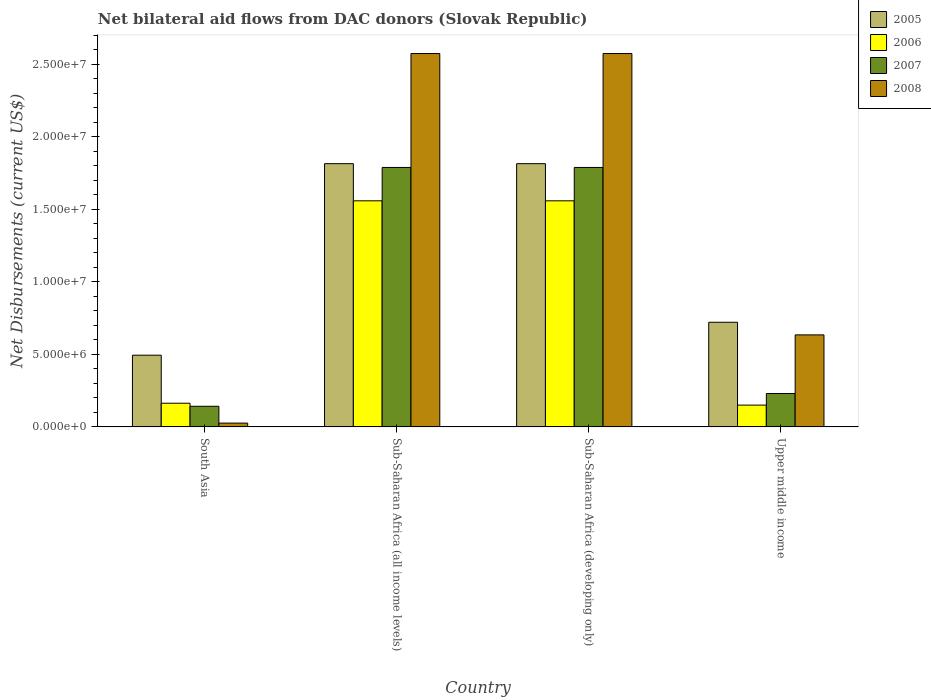Are the number of bars on each tick of the X-axis equal?
Make the answer very short. Yes. What is the label of the 2nd group of bars from the left?
Provide a succinct answer. Sub-Saharan Africa (all income levels). What is the net bilateral aid flows in 2006 in South Asia?
Provide a short and direct response. 1.63e+06. Across all countries, what is the maximum net bilateral aid flows in 2008?
Give a very brief answer. 2.57e+07. Across all countries, what is the minimum net bilateral aid flows in 2005?
Ensure brevity in your answer.  4.94e+06. In which country was the net bilateral aid flows in 2005 maximum?
Ensure brevity in your answer.  Sub-Saharan Africa (all income levels). What is the total net bilateral aid flows in 2005 in the graph?
Your response must be concise. 4.84e+07. What is the difference between the net bilateral aid flows in 2007 in South Asia and that in Upper middle income?
Keep it short and to the point. -8.80e+05. What is the difference between the net bilateral aid flows in 2006 in Upper middle income and the net bilateral aid flows in 2008 in Sub-Saharan Africa (all income levels)?
Ensure brevity in your answer.  -2.42e+07. What is the average net bilateral aid flows in 2008 per country?
Your response must be concise. 1.45e+07. What is the difference between the net bilateral aid flows of/in 2008 and net bilateral aid flows of/in 2005 in Upper middle income?
Your answer should be very brief. -8.70e+05. In how many countries, is the net bilateral aid flows in 2005 greater than 13000000 US$?
Your answer should be very brief. 2. What is the ratio of the net bilateral aid flows in 2005 in Sub-Saharan Africa (developing only) to that in Upper middle income?
Keep it short and to the point. 2.52. Is the net bilateral aid flows in 2005 in South Asia less than that in Sub-Saharan Africa (developing only)?
Keep it short and to the point. Yes. What is the difference between the highest and the second highest net bilateral aid flows in 2006?
Your answer should be very brief. 1.40e+07. What is the difference between the highest and the lowest net bilateral aid flows in 2007?
Keep it short and to the point. 1.65e+07. In how many countries, is the net bilateral aid flows in 2006 greater than the average net bilateral aid flows in 2006 taken over all countries?
Your answer should be very brief. 2. Is the sum of the net bilateral aid flows in 2008 in Sub-Saharan Africa (all income levels) and Sub-Saharan Africa (developing only) greater than the maximum net bilateral aid flows in 2005 across all countries?
Offer a terse response. Yes. Is it the case that in every country, the sum of the net bilateral aid flows in 2006 and net bilateral aid flows in 2007 is greater than the net bilateral aid flows in 2005?
Give a very brief answer. No. How many bars are there?
Make the answer very short. 16. Are all the bars in the graph horizontal?
Your response must be concise. No. What is the difference between two consecutive major ticks on the Y-axis?
Provide a short and direct response. 5.00e+06. Does the graph contain grids?
Your answer should be compact. No. What is the title of the graph?
Give a very brief answer. Net bilateral aid flows from DAC donors (Slovak Republic). What is the label or title of the X-axis?
Give a very brief answer. Country. What is the label or title of the Y-axis?
Your answer should be very brief. Net Disbursements (current US$). What is the Net Disbursements (current US$) of 2005 in South Asia?
Provide a short and direct response. 4.94e+06. What is the Net Disbursements (current US$) in 2006 in South Asia?
Ensure brevity in your answer.  1.63e+06. What is the Net Disbursements (current US$) of 2007 in South Asia?
Your response must be concise. 1.42e+06. What is the Net Disbursements (current US$) in 2008 in South Asia?
Make the answer very short. 2.60e+05. What is the Net Disbursements (current US$) in 2005 in Sub-Saharan Africa (all income levels)?
Make the answer very short. 1.81e+07. What is the Net Disbursements (current US$) in 2006 in Sub-Saharan Africa (all income levels)?
Ensure brevity in your answer.  1.56e+07. What is the Net Disbursements (current US$) in 2007 in Sub-Saharan Africa (all income levels)?
Your answer should be very brief. 1.79e+07. What is the Net Disbursements (current US$) of 2008 in Sub-Saharan Africa (all income levels)?
Your response must be concise. 2.57e+07. What is the Net Disbursements (current US$) in 2005 in Sub-Saharan Africa (developing only)?
Provide a short and direct response. 1.81e+07. What is the Net Disbursements (current US$) in 2006 in Sub-Saharan Africa (developing only)?
Your answer should be compact. 1.56e+07. What is the Net Disbursements (current US$) of 2007 in Sub-Saharan Africa (developing only)?
Your answer should be compact. 1.79e+07. What is the Net Disbursements (current US$) in 2008 in Sub-Saharan Africa (developing only)?
Ensure brevity in your answer.  2.57e+07. What is the Net Disbursements (current US$) in 2005 in Upper middle income?
Your answer should be compact. 7.21e+06. What is the Net Disbursements (current US$) in 2006 in Upper middle income?
Your answer should be compact. 1.50e+06. What is the Net Disbursements (current US$) of 2007 in Upper middle income?
Provide a short and direct response. 2.30e+06. What is the Net Disbursements (current US$) of 2008 in Upper middle income?
Provide a succinct answer. 6.34e+06. Across all countries, what is the maximum Net Disbursements (current US$) of 2005?
Ensure brevity in your answer.  1.81e+07. Across all countries, what is the maximum Net Disbursements (current US$) of 2006?
Give a very brief answer. 1.56e+07. Across all countries, what is the maximum Net Disbursements (current US$) of 2007?
Give a very brief answer. 1.79e+07. Across all countries, what is the maximum Net Disbursements (current US$) of 2008?
Offer a terse response. 2.57e+07. Across all countries, what is the minimum Net Disbursements (current US$) in 2005?
Provide a succinct answer. 4.94e+06. Across all countries, what is the minimum Net Disbursements (current US$) in 2006?
Ensure brevity in your answer.  1.50e+06. Across all countries, what is the minimum Net Disbursements (current US$) in 2007?
Offer a terse response. 1.42e+06. Across all countries, what is the minimum Net Disbursements (current US$) in 2008?
Provide a short and direct response. 2.60e+05. What is the total Net Disbursements (current US$) of 2005 in the graph?
Offer a very short reply. 4.84e+07. What is the total Net Disbursements (current US$) in 2006 in the graph?
Ensure brevity in your answer.  3.43e+07. What is the total Net Disbursements (current US$) in 2007 in the graph?
Provide a short and direct response. 3.95e+07. What is the total Net Disbursements (current US$) of 2008 in the graph?
Your answer should be very brief. 5.81e+07. What is the difference between the Net Disbursements (current US$) of 2005 in South Asia and that in Sub-Saharan Africa (all income levels)?
Ensure brevity in your answer.  -1.32e+07. What is the difference between the Net Disbursements (current US$) of 2006 in South Asia and that in Sub-Saharan Africa (all income levels)?
Your answer should be very brief. -1.40e+07. What is the difference between the Net Disbursements (current US$) in 2007 in South Asia and that in Sub-Saharan Africa (all income levels)?
Provide a short and direct response. -1.65e+07. What is the difference between the Net Disbursements (current US$) in 2008 in South Asia and that in Sub-Saharan Africa (all income levels)?
Provide a succinct answer. -2.55e+07. What is the difference between the Net Disbursements (current US$) in 2005 in South Asia and that in Sub-Saharan Africa (developing only)?
Give a very brief answer. -1.32e+07. What is the difference between the Net Disbursements (current US$) of 2006 in South Asia and that in Sub-Saharan Africa (developing only)?
Ensure brevity in your answer.  -1.40e+07. What is the difference between the Net Disbursements (current US$) of 2007 in South Asia and that in Sub-Saharan Africa (developing only)?
Offer a terse response. -1.65e+07. What is the difference between the Net Disbursements (current US$) of 2008 in South Asia and that in Sub-Saharan Africa (developing only)?
Make the answer very short. -2.55e+07. What is the difference between the Net Disbursements (current US$) in 2005 in South Asia and that in Upper middle income?
Your response must be concise. -2.27e+06. What is the difference between the Net Disbursements (current US$) in 2006 in South Asia and that in Upper middle income?
Keep it short and to the point. 1.30e+05. What is the difference between the Net Disbursements (current US$) of 2007 in South Asia and that in Upper middle income?
Offer a terse response. -8.80e+05. What is the difference between the Net Disbursements (current US$) in 2008 in South Asia and that in Upper middle income?
Offer a terse response. -6.08e+06. What is the difference between the Net Disbursements (current US$) in 2006 in Sub-Saharan Africa (all income levels) and that in Sub-Saharan Africa (developing only)?
Provide a succinct answer. 0. What is the difference between the Net Disbursements (current US$) of 2007 in Sub-Saharan Africa (all income levels) and that in Sub-Saharan Africa (developing only)?
Offer a terse response. 0. What is the difference between the Net Disbursements (current US$) in 2005 in Sub-Saharan Africa (all income levels) and that in Upper middle income?
Provide a short and direct response. 1.09e+07. What is the difference between the Net Disbursements (current US$) in 2006 in Sub-Saharan Africa (all income levels) and that in Upper middle income?
Your answer should be very brief. 1.41e+07. What is the difference between the Net Disbursements (current US$) of 2007 in Sub-Saharan Africa (all income levels) and that in Upper middle income?
Provide a short and direct response. 1.56e+07. What is the difference between the Net Disbursements (current US$) of 2008 in Sub-Saharan Africa (all income levels) and that in Upper middle income?
Ensure brevity in your answer.  1.94e+07. What is the difference between the Net Disbursements (current US$) in 2005 in Sub-Saharan Africa (developing only) and that in Upper middle income?
Give a very brief answer. 1.09e+07. What is the difference between the Net Disbursements (current US$) in 2006 in Sub-Saharan Africa (developing only) and that in Upper middle income?
Offer a terse response. 1.41e+07. What is the difference between the Net Disbursements (current US$) of 2007 in Sub-Saharan Africa (developing only) and that in Upper middle income?
Ensure brevity in your answer.  1.56e+07. What is the difference between the Net Disbursements (current US$) of 2008 in Sub-Saharan Africa (developing only) and that in Upper middle income?
Your answer should be very brief. 1.94e+07. What is the difference between the Net Disbursements (current US$) of 2005 in South Asia and the Net Disbursements (current US$) of 2006 in Sub-Saharan Africa (all income levels)?
Keep it short and to the point. -1.06e+07. What is the difference between the Net Disbursements (current US$) of 2005 in South Asia and the Net Disbursements (current US$) of 2007 in Sub-Saharan Africa (all income levels)?
Offer a terse response. -1.29e+07. What is the difference between the Net Disbursements (current US$) of 2005 in South Asia and the Net Disbursements (current US$) of 2008 in Sub-Saharan Africa (all income levels)?
Your answer should be very brief. -2.08e+07. What is the difference between the Net Disbursements (current US$) in 2006 in South Asia and the Net Disbursements (current US$) in 2007 in Sub-Saharan Africa (all income levels)?
Provide a succinct answer. -1.62e+07. What is the difference between the Net Disbursements (current US$) of 2006 in South Asia and the Net Disbursements (current US$) of 2008 in Sub-Saharan Africa (all income levels)?
Provide a short and direct response. -2.41e+07. What is the difference between the Net Disbursements (current US$) in 2007 in South Asia and the Net Disbursements (current US$) in 2008 in Sub-Saharan Africa (all income levels)?
Offer a terse response. -2.43e+07. What is the difference between the Net Disbursements (current US$) of 2005 in South Asia and the Net Disbursements (current US$) of 2006 in Sub-Saharan Africa (developing only)?
Give a very brief answer. -1.06e+07. What is the difference between the Net Disbursements (current US$) of 2005 in South Asia and the Net Disbursements (current US$) of 2007 in Sub-Saharan Africa (developing only)?
Offer a terse response. -1.29e+07. What is the difference between the Net Disbursements (current US$) in 2005 in South Asia and the Net Disbursements (current US$) in 2008 in Sub-Saharan Africa (developing only)?
Offer a terse response. -2.08e+07. What is the difference between the Net Disbursements (current US$) of 2006 in South Asia and the Net Disbursements (current US$) of 2007 in Sub-Saharan Africa (developing only)?
Offer a very short reply. -1.62e+07. What is the difference between the Net Disbursements (current US$) in 2006 in South Asia and the Net Disbursements (current US$) in 2008 in Sub-Saharan Africa (developing only)?
Provide a succinct answer. -2.41e+07. What is the difference between the Net Disbursements (current US$) in 2007 in South Asia and the Net Disbursements (current US$) in 2008 in Sub-Saharan Africa (developing only)?
Make the answer very short. -2.43e+07. What is the difference between the Net Disbursements (current US$) in 2005 in South Asia and the Net Disbursements (current US$) in 2006 in Upper middle income?
Offer a terse response. 3.44e+06. What is the difference between the Net Disbursements (current US$) in 2005 in South Asia and the Net Disbursements (current US$) in 2007 in Upper middle income?
Make the answer very short. 2.64e+06. What is the difference between the Net Disbursements (current US$) in 2005 in South Asia and the Net Disbursements (current US$) in 2008 in Upper middle income?
Give a very brief answer. -1.40e+06. What is the difference between the Net Disbursements (current US$) in 2006 in South Asia and the Net Disbursements (current US$) in 2007 in Upper middle income?
Offer a terse response. -6.70e+05. What is the difference between the Net Disbursements (current US$) in 2006 in South Asia and the Net Disbursements (current US$) in 2008 in Upper middle income?
Your answer should be compact. -4.71e+06. What is the difference between the Net Disbursements (current US$) in 2007 in South Asia and the Net Disbursements (current US$) in 2008 in Upper middle income?
Offer a very short reply. -4.92e+06. What is the difference between the Net Disbursements (current US$) in 2005 in Sub-Saharan Africa (all income levels) and the Net Disbursements (current US$) in 2006 in Sub-Saharan Africa (developing only)?
Provide a short and direct response. 2.56e+06. What is the difference between the Net Disbursements (current US$) of 2005 in Sub-Saharan Africa (all income levels) and the Net Disbursements (current US$) of 2008 in Sub-Saharan Africa (developing only)?
Ensure brevity in your answer.  -7.59e+06. What is the difference between the Net Disbursements (current US$) in 2006 in Sub-Saharan Africa (all income levels) and the Net Disbursements (current US$) in 2007 in Sub-Saharan Africa (developing only)?
Provide a short and direct response. -2.30e+06. What is the difference between the Net Disbursements (current US$) of 2006 in Sub-Saharan Africa (all income levels) and the Net Disbursements (current US$) of 2008 in Sub-Saharan Africa (developing only)?
Keep it short and to the point. -1.02e+07. What is the difference between the Net Disbursements (current US$) of 2007 in Sub-Saharan Africa (all income levels) and the Net Disbursements (current US$) of 2008 in Sub-Saharan Africa (developing only)?
Provide a succinct answer. -7.85e+06. What is the difference between the Net Disbursements (current US$) of 2005 in Sub-Saharan Africa (all income levels) and the Net Disbursements (current US$) of 2006 in Upper middle income?
Offer a terse response. 1.66e+07. What is the difference between the Net Disbursements (current US$) in 2005 in Sub-Saharan Africa (all income levels) and the Net Disbursements (current US$) in 2007 in Upper middle income?
Your answer should be very brief. 1.58e+07. What is the difference between the Net Disbursements (current US$) of 2005 in Sub-Saharan Africa (all income levels) and the Net Disbursements (current US$) of 2008 in Upper middle income?
Your response must be concise. 1.18e+07. What is the difference between the Net Disbursements (current US$) of 2006 in Sub-Saharan Africa (all income levels) and the Net Disbursements (current US$) of 2007 in Upper middle income?
Offer a very short reply. 1.33e+07. What is the difference between the Net Disbursements (current US$) in 2006 in Sub-Saharan Africa (all income levels) and the Net Disbursements (current US$) in 2008 in Upper middle income?
Your response must be concise. 9.24e+06. What is the difference between the Net Disbursements (current US$) of 2007 in Sub-Saharan Africa (all income levels) and the Net Disbursements (current US$) of 2008 in Upper middle income?
Your response must be concise. 1.15e+07. What is the difference between the Net Disbursements (current US$) of 2005 in Sub-Saharan Africa (developing only) and the Net Disbursements (current US$) of 2006 in Upper middle income?
Your response must be concise. 1.66e+07. What is the difference between the Net Disbursements (current US$) of 2005 in Sub-Saharan Africa (developing only) and the Net Disbursements (current US$) of 2007 in Upper middle income?
Give a very brief answer. 1.58e+07. What is the difference between the Net Disbursements (current US$) in 2005 in Sub-Saharan Africa (developing only) and the Net Disbursements (current US$) in 2008 in Upper middle income?
Your answer should be very brief. 1.18e+07. What is the difference between the Net Disbursements (current US$) of 2006 in Sub-Saharan Africa (developing only) and the Net Disbursements (current US$) of 2007 in Upper middle income?
Give a very brief answer. 1.33e+07. What is the difference between the Net Disbursements (current US$) of 2006 in Sub-Saharan Africa (developing only) and the Net Disbursements (current US$) of 2008 in Upper middle income?
Give a very brief answer. 9.24e+06. What is the difference between the Net Disbursements (current US$) of 2007 in Sub-Saharan Africa (developing only) and the Net Disbursements (current US$) of 2008 in Upper middle income?
Make the answer very short. 1.15e+07. What is the average Net Disbursements (current US$) in 2005 per country?
Your answer should be very brief. 1.21e+07. What is the average Net Disbursements (current US$) of 2006 per country?
Provide a short and direct response. 8.57e+06. What is the average Net Disbursements (current US$) of 2007 per country?
Give a very brief answer. 9.87e+06. What is the average Net Disbursements (current US$) in 2008 per country?
Keep it short and to the point. 1.45e+07. What is the difference between the Net Disbursements (current US$) of 2005 and Net Disbursements (current US$) of 2006 in South Asia?
Offer a very short reply. 3.31e+06. What is the difference between the Net Disbursements (current US$) of 2005 and Net Disbursements (current US$) of 2007 in South Asia?
Your answer should be very brief. 3.52e+06. What is the difference between the Net Disbursements (current US$) of 2005 and Net Disbursements (current US$) of 2008 in South Asia?
Your answer should be very brief. 4.68e+06. What is the difference between the Net Disbursements (current US$) of 2006 and Net Disbursements (current US$) of 2008 in South Asia?
Offer a terse response. 1.37e+06. What is the difference between the Net Disbursements (current US$) in 2007 and Net Disbursements (current US$) in 2008 in South Asia?
Give a very brief answer. 1.16e+06. What is the difference between the Net Disbursements (current US$) of 2005 and Net Disbursements (current US$) of 2006 in Sub-Saharan Africa (all income levels)?
Provide a short and direct response. 2.56e+06. What is the difference between the Net Disbursements (current US$) of 2005 and Net Disbursements (current US$) of 2007 in Sub-Saharan Africa (all income levels)?
Make the answer very short. 2.60e+05. What is the difference between the Net Disbursements (current US$) of 2005 and Net Disbursements (current US$) of 2008 in Sub-Saharan Africa (all income levels)?
Keep it short and to the point. -7.59e+06. What is the difference between the Net Disbursements (current US$) in 2006 and Net Disbursements (current US$) in 2007 in Sub-Saharan Africa (all income levels)?
Keep it short and to the point. -2.30e+06. What is the difference between the Net Disbursements (current US$) of 2006 and Net Disbursements (current US$) of 2008 in Sub-Saharan Africa (all income levels)?
Give a very brief answer. -1.02e+07. What is the difference between the Net Disbursements (current US$) of 2007 and Net Disbursements (current US$) of 2008 in Sub-Saharan Africa (all income levels)?
Your answer should be compact. -7.85e+06. What is the difference between the Net Disbursements (current US$) in 2005 and Net Disbursements (current US$) in 2006 in Sub-Saharan Africa (developing only)?
Provide a succinct answer. 2.56e+06. What is the difference between the Net Disbursements (current US$) of 2005 and Net Disbursements (current US$) of 2008 in Sub-Saharan Africa (developing only)?
Provide a succinct answer. -7.59e+06. What is the difference between the Net Disbursements (current US$) of 2006 and Net Disbursements (current US$) of 2007 in Sub-Saharan Africa (developing only)?
Your answer should be very brief. -2.30e+06. What is the difference between the Net Disbursements (current US$) of 2006 and Net Disbursements (current US$) of 2008 in Sub-Saharan Africa (developing only)?
Ensure brevity in your answer.  -1.02e+07. What is the difference between the Net Disbursements (current US$) of 2007 and Net Disbursements (current US$) of 2008 in Sub-Saharan Africa (developing only)?
Your answer should be compact. -7.85e+06. What is the difference between the Net Disbursements (current US$) of 2005 and Net Disbursements (current US$) of 2006 in Upper middle income?
Provide a short and direct response. 5.71e+06. What is the difference between the Net Disbursements (current US$) in 2005 and Net Disbursements (current US$) in 2007 in Upper middle income?
Provide a short and direct response. 4.91e+06. What is the difference between the Net Disbursements (current US$) of 2005 and Net Disbursements (current US$) of 2008 in Upper middle income?
Give a very brief answer. 8.70e+05. What is the difference between the Net Disbursements (current US$) in 2006 and Net Disbursements (current US$) in 2007 in Upper middle income?
Provide a succinct answer. -8.00e+05. What is the difference between the Net Disbursements (current US$) of 2006 and Net Disbursements (current US$) of 2008 in Upper middle income?
Your response must be concise. -4.84e+06. What is the difference between the Net Disbursements (current US$) of 2007 and Net Disbursements (current US$) of 2008 in Upper middle income?
Ensure brevity in your answer.  -4.04e+06. What is the ratio of the Net Disbursements (current US$) in 2005 in South Asia to that in Sub-Saharan Africa (all income levels)?
Offer a very short reply. 0.27. What is the ratio of the Net Disbursements (current US$) in 2006 in South Asia to that in Sub-Saharan Africa (all income levels)?
Give a very brief answer. 0.1. What is the ratio of the Net Disbursements (current US$) in 2007 in South Asia to that in Sub-Saharan Africa (all income levels)?
Your answer should be compact. 0.08. What is the ratio of the Net Disbursements (current US$) in 2008 in South Asia to that in Sub-Saharan Africa (all income levels)?
Offer a terse response. 0.01. What is the ratio of the Net Disbursements (current US$) in 2005 in South Asia to that in Sub-Saharan Africa (developing only)?
Keep it short and to the point. 0.27. What is the ratio of the Net Disbursements (current US$) of 2006 in South Asia to that in Sub-Saharan Africa (developing only)?
Provide a succinct answer. 0.1. What is the ratio of the Net Disbursements (current US$) in 2007 in South Asia to that in Sub-Saharan Africa (developing only)?
Ensure brevity in your answer.  0.08. What is the ratio of the Net Disbursements (current US$) in 2008 in South Asia to that in Sub-Saharan Africa (developing only)?
Give a very brief answer. 0.01. What is the ratio of the Net Disbursements (current US$) in 2005 in South Asia to that in Upper middle income?
Give a very brief answer. 0.69. What is the ratio of the Net Disbursements (current US$) of 2006 in South Asia to that in Upper middle income?
Give a very brief answer. 1.09. What is the ratio of the Net Disbursements (current US$) of 2007 in South Asia to that in Upper middle income?
Provide a succinct answer. 0.62. What is the ratio of the Net Disbursements (current US$) of 2008 in South Asia to that in Upper middle income?
Your answer should be compact. 0.04. What is the ratio of the Net Disbursements (current US$) of 2005 in Sub-Saharan Africa (all income levels) to that in Sub-Saharan Africa (developing only)?
Give a very brief answer. 1. What is the ratio of the Net Disbursements (current US$) of 2007 in Sub-Saharan Africa (all income levels) to that in Sub-Saharan Africa (developing only)?
Offer a very short reply. 1. What is the ratio of the Net Disbursements (current US$) of 2005 in Sub-Saharan Africa (all income levels) to that in Upper middle income?
Your answer should be compact. 2.52. What is the ratio of the Net Disbursements (current US$) in 2006 in Sub-Saharan Africa (all income levels) to that in Upper middle income?
Your answer should be compact. 10.39. What is the ratio of the Net Disbursements (current US$) in 2007 in Sub-Saharan Africa (all income levels) to that in Upper middle income?
Provide a short and direct response. 7.77. What is the ratio of the Net Disbursements (current US$) of 2008 in Sub-Saharan Africa (all income levels) to that in Upper middle income?
Give a very brief answer. 4.06. What is the ratio of the Net Disbursements (current US$) of 2005 in Sub-Saharan Africa (developing only) to that in Upper middle income?
Provide a short and direct response. 2.52. What is the ratio of the Net Disbursements (current US$) of 2006 in Sub-Saharan Africa (developing only) to that in Upper middle income?
Your answer should be very brief. 10.39. What is the ratio of the Net Disbursements (current US$) in 2007 in Sub-Saharan Africa (developing only) to that in Upper middle income?
Offer a terse response. 7.77. What is the ratio of the Net Disbursements (current US$) of 2008 in Sub-Saharan Africa (developing only) to that in Upper middle income?
Your response must be concise. 4.06. What is the difference between the highest and the second highest Net Disbursements (current US$) of 2006?
Your response must be concise. 0. What is the difference between the highest and the lowest Net Disbursements (current US$) of 2005?
Provide a succinct answer. 1.32e+07. What is the difference between the highest and the lowest Net Disbursements (current US$) in 2006?
Make the answer very short. 1.41e+07. What is the difference between the highest and the lowest Net Disbursements (current US$) in 2007?
Offer a terse response. 1.65e+07. What is the difference between the highest and the lowest Net Disbursements (current US$) of 2008?
Your answer should be compact. 2.55e+07. 